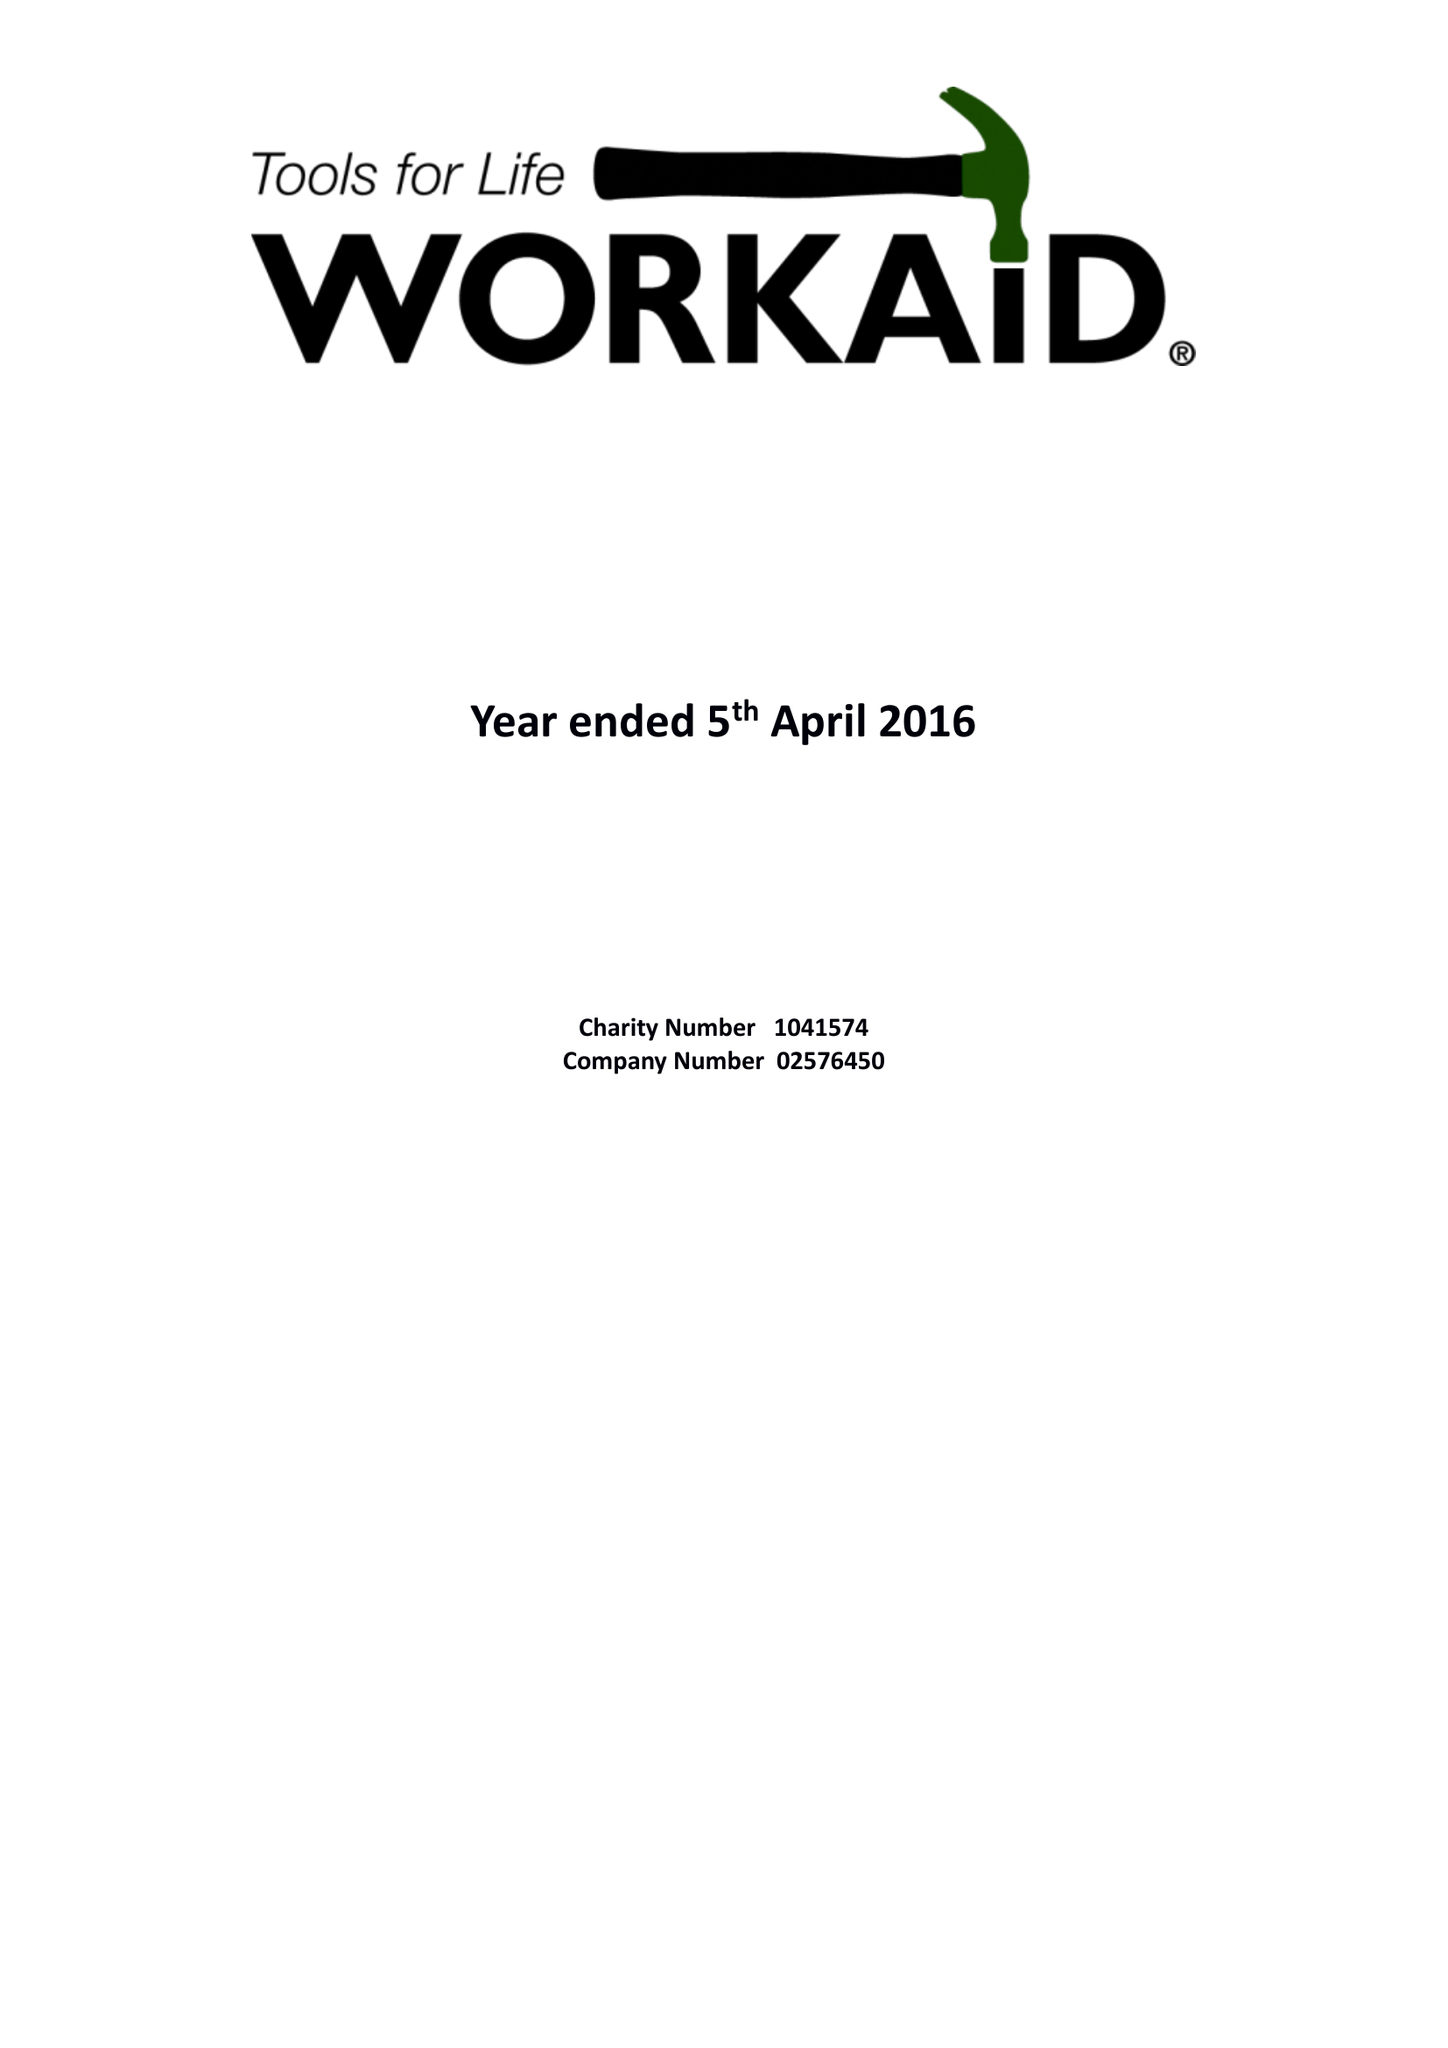What is the value for the address__postcode?
Answer the question using a single word or phrase. HP5 2AA 